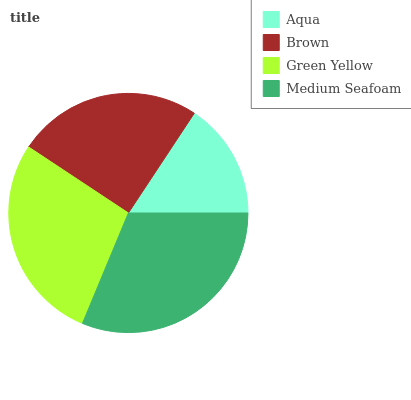Is Aqua the minimum?
Answer yes or no. Yes. Is Medium Seafoam the maximum?
Answer yes or no. Yes. Is Brown the minimum?
Answer yes or no. No. Is Brown the maximum?
Answer yes or no. No. Is Brown greater than Aqua?
Answer yes or no. Yes. Is Aqua less than Brown?
Answer yes or no. Yes. Is Aqua greater than Brown?
Answer yes or no. No. Is Brown less than Aqua?
Answer yes or no. No. Is Green Yellow the high median?
Answer yes or no. Yes. Is Brown the low median?
Answer yes or no. Yes. Is Brown the high median?
Answer yes or no. No. Is Aqua the low median?
Answer yes or no. No. 